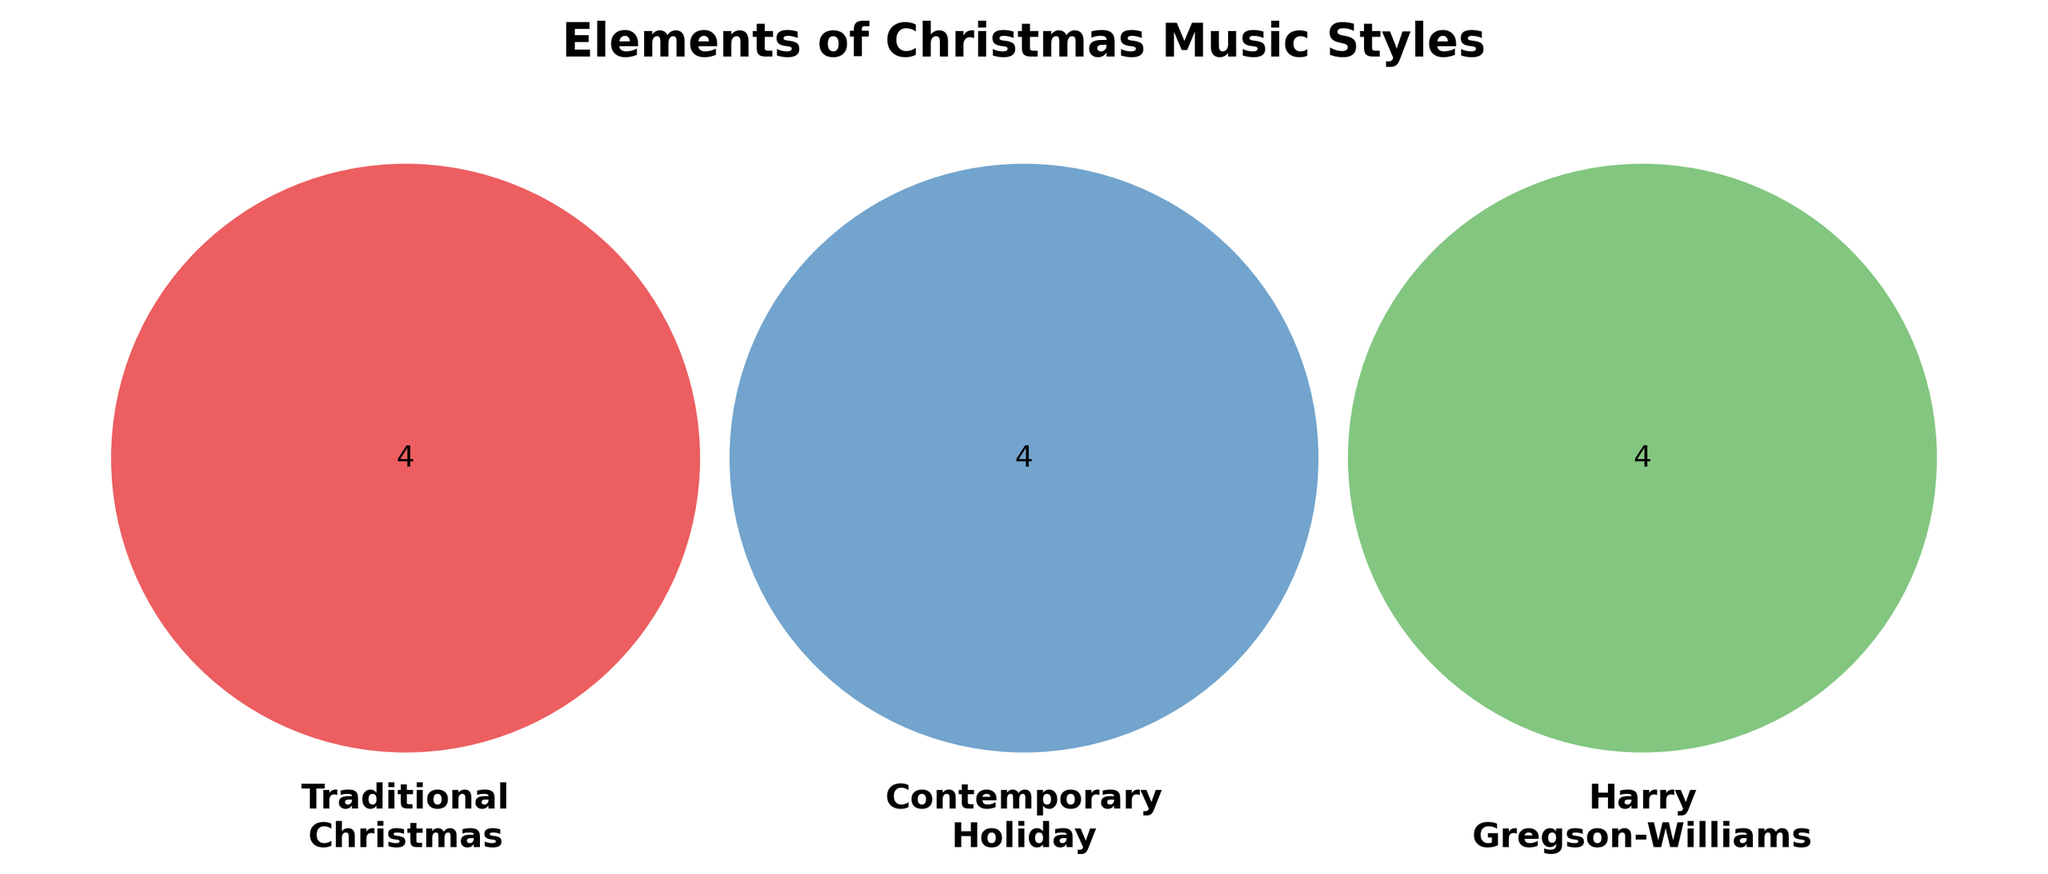What's the title of the figure? The title of the figure is prominently placed at the top of the diagram. It reads "Elements of Christmas Music Styles".
Answer: Elements of Christmas Music Styles Which style includes "Bell sounds"? In the Venn diagram, "Bell sounds" is listed within the section representing "Traditional Christmas Soundtracks".
Answer: Traditional Christmas Soundtracks Which styles share "Modern production techniques"? "Modern production techniques" appears in the overlapping section between "Contemporary Holiday Music" and "Harry Gregson-Williams' Style".
Answer: Contemporary Holiday Music and Harry Gregson-Williams' Style How many elements are unique to Contemporary Holiday Music? By looking at the diagram, we can count the elements unique to Contemporary Holiday Music. They are "Pop influences", "Electronic elements", "Upbeat tempos", and "Secular themes". There are 4 elements in total.
Answer: 4 Which element is common to all three styles? The element that appears in the center where all three circles overlap is "Storytelling through music".
Answer: Storytelling through music What element is common to Traditional Christmas Soundtracks and Harry Gregson-Williams' Style but not Contemporary Holiday Music? The element found in the overlapping section between Traditional Christmas Soundtracks and Harry Gregson-Williams' Style, but not in Contemporary Holiday Music is "Rich instrumental textures".
Answer: Rich instrumental textures Which elements reflect Harry Gregson-Williams' use of electronic music? From the Harry Gregson-Williams' Style section, the element that reflects his use of electronic music is "Electronic integration".
Answer: Electronic integration Count the total number of unique elements in the diagram. We sum up all the unique elements from each category and their intersections (excluding repeated ones). There are 4 elements in Traditional Christmas Soundtracks, 4 in Contemporary Holiday Music, 4 in Harry Gregson-Williams' Style, 1 shared between all three, and a few more shared between specific pairs. Counting them, we have a total of 12 unique elements.
Answer: 12 elements 